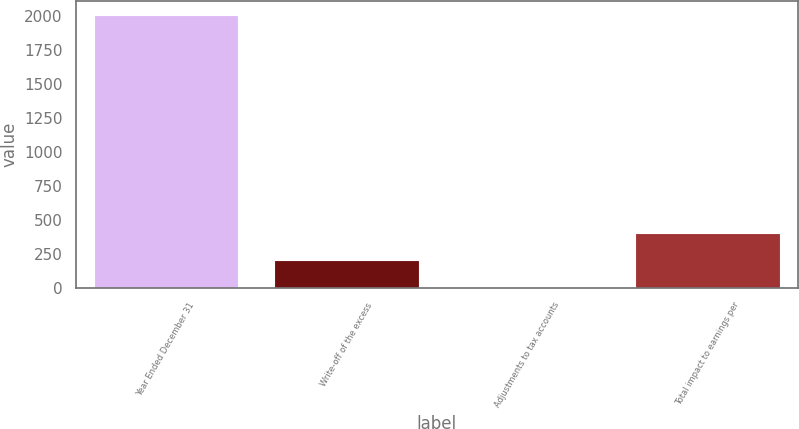Convert chart. <chart><loc_0><loc_0><loc_500><loc_500><bar_chart><fcel>Year Ended December 31<fcel>Write-off of the excess<fcel>Adjustments to tax accounts<fcel>Total impact to earnings per<nl><fcel>2008<fcel>200.82<fcel>0.02<fcel>401.62<nl></chart> 